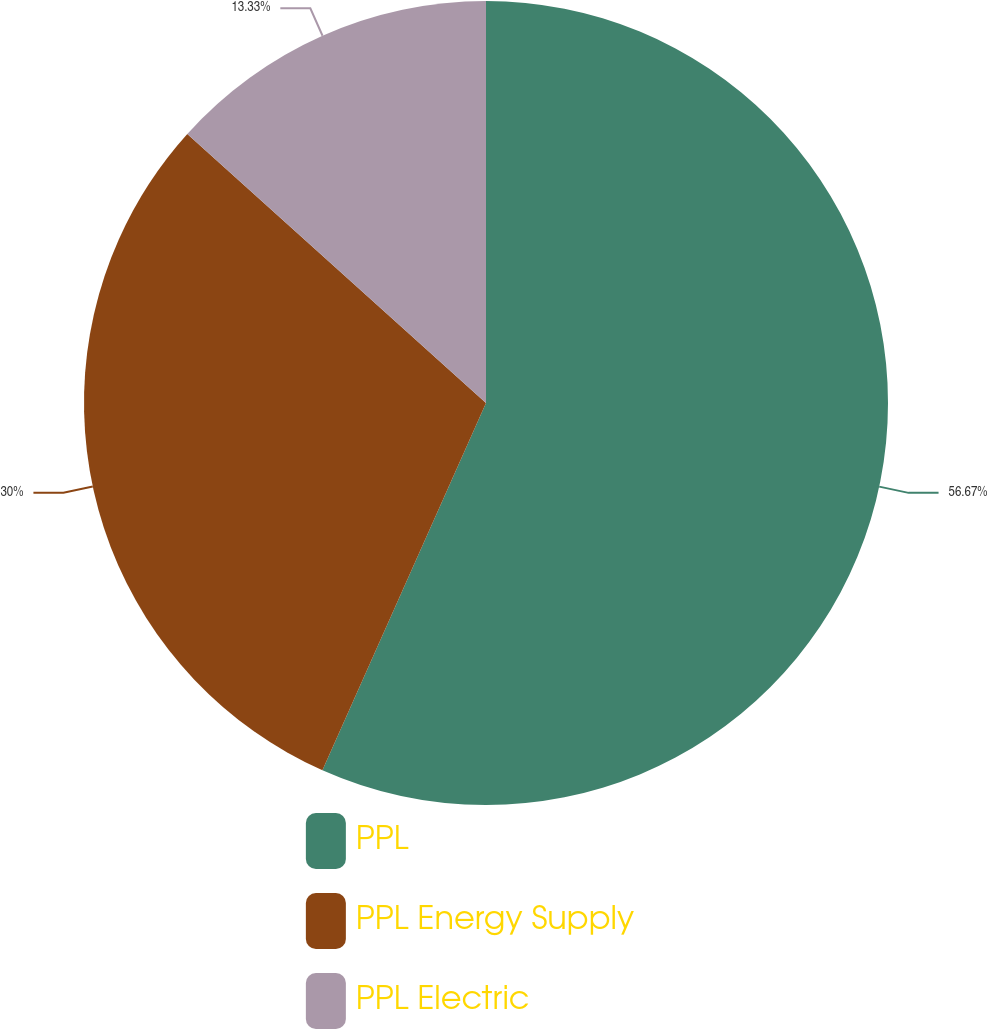Convert chart to OTSL. <chart><loc_0><loc_0><loc_500><loc_500><pie_chart><fcel>PPL<fcel>PPL Energy Supply<fcel>PPL Electric<nl><fcel>56.67%<fcel>30.0%<fcel>13.33%<nl></chart> 